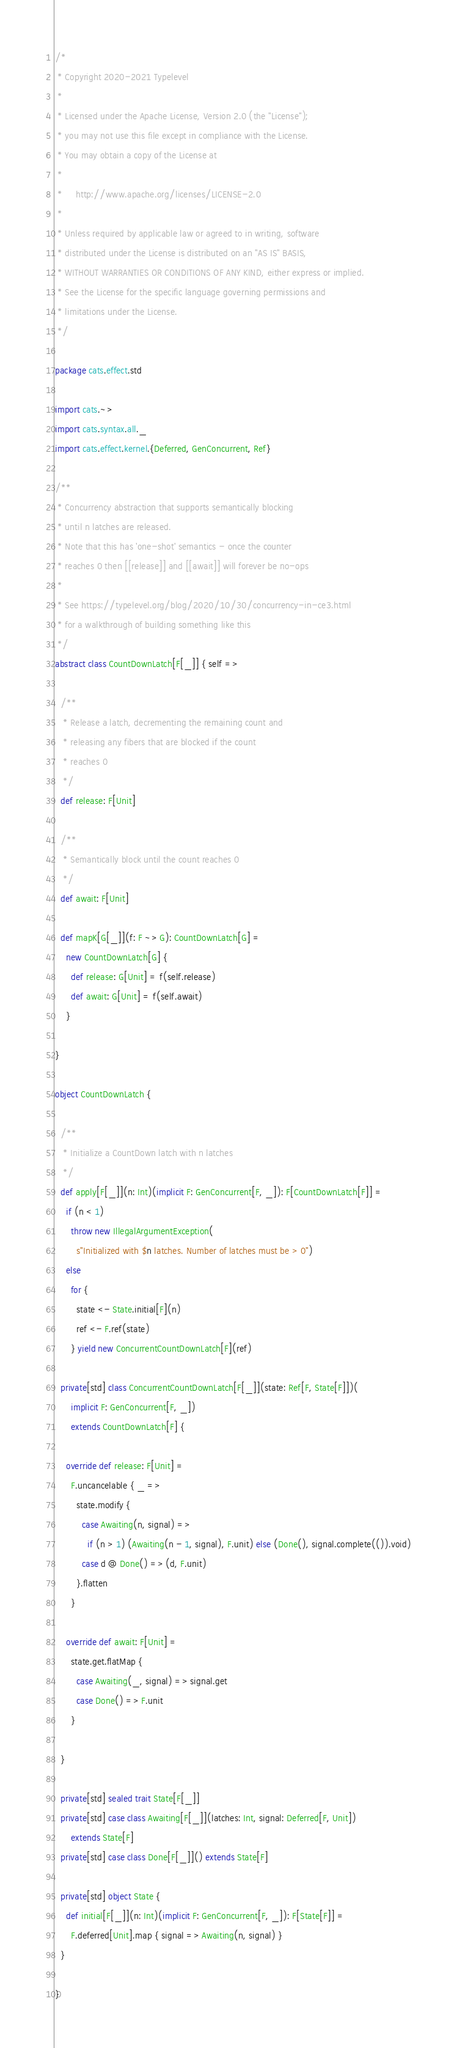<code> <loc_0><loc_0><loc_500><loc_500><_Scala_>/*
 * Copyright 2020-2021 Typelevel
 *
 * Licensed under the Apache License, Version 2.0 (the "License");
 * you may not use this file except in compliance with the License.
 * You may obtain a copy of the License at
 *
 *     http://www.apache.org/licenses/LICENSE-2.0
 *
 * Unless required by applicable law or agreed to in writing, software
 * distributed under the License is distributed on an "AS IS" BASIS,
 * WITHOUT WARRANTIES OR CONDITIONS OF ANY KIND, either express or implied.
 * See the License for the specific language governing permissions and
 * limitations under the License.
 */

package cats.effect.std

import cats.~>
import cats.syntax.all._
import cats.effect.kernel.{Deferred, GenConcurrent, Ref}

/**
 * Concurrency abstraction that supports semantically blocking
 * until n latches are released.
 * Note that this has 'one-shot' semantics - once the counter
 * reaches 0 then [[release]] and [[await]] will forever be no-ops
 *
 * See https://typelevel.org/blog/2020/10/30/concurrency-in-ce3.html
 * for a walkthrough of building something like this
 */
abstract class CountDownLatch[F[_]] { self =>

  /**
   * Release a latch, decrementing the remaining count and
   * releasing any fibers that are blocked if the count
   * reaches 0
   */
  def release: F[Unit]

  /**
   * Semantically block until the count reaches 0
   */
  def await: F[Unit]

  def mapK[G[_]](f: F ~> G): CountDownLatch[G] =
    new CountDownLatch[G] {
      def release: G[Unit] = f(self.release)
      def await: G[Unit] = f(self.await)
    }

}

object CountDownLatch {

  /**
   * Initialize a CountDown latch with n latches
   */
  def apply[F[_]](n: Int)(implicit F: GenConcurrent[F, _]): F[CountDownLatch[F]] =
    if (n < 1)
      throw new IllegalArgumentException(
        s"Initialized with $n latches. Number of latches must be > 0")
    else
      for {
        state <- State.initial[F](n)
        ref <- F.ref(state)
      } yield new ConcurrentCountDownLatch[F](ref)

  private[std] class ConcurrentCountDownLatch[F[_]](state: Ref[F, State[F]])(
      implicit F: GenConcurrent[F, _])
      extends CountDownLatch[F] {

    override def release: F[Unit] =
      F.uncancelable { _ =>
        state.modify {
          case Awaiting(n, signal) =>
            if (n > 1) (Awaiting(n - 1, signal), F.unit) else (Done(), signal.complete(()).void)
          case d @ Done() => (d, F.unit)
        }.flatten
      }

    override def await: F[Unit] =
      state.get.flatMap {
        case Awaiting(_, signal) => signal.get
        case Done() => F.unit
      }

  }

  private[std] sealed trait State[F[_]]
  private[std] case class Awaiting[F[_]](latches: Int, signal: Deferred[F, Unit])
      extends State[F]
  private[std] case class Done[F[_]]() extends State[F]

  private[std] object State {
    def initial[F[_]](n: Int)(implicit F: GenConcurrent[F, _]): F[State[F]] =
      F.deferred[Unit].map { signal => Awaiting(n, signal) }
  }

}
</code> 